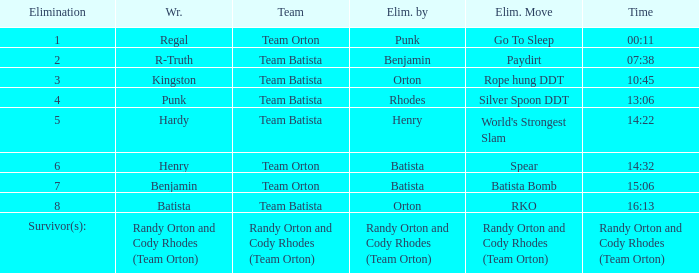At what hour was the wrestler henry ousted by batista? 14:32. 